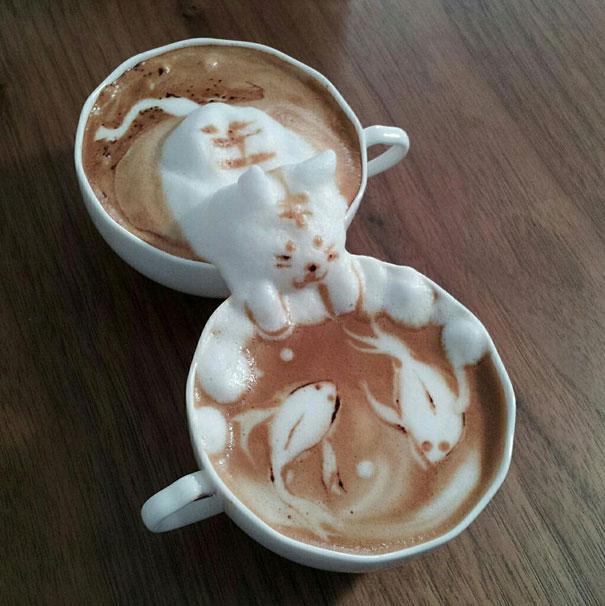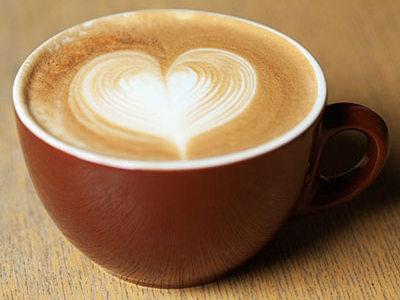The first image is the image on the left, the second image is the image on the right. Given the left and right images, does the statement "There is a milk design in a coffee." hold true? Answer yes or no. Yes. The first image is the image on the left, the second image is the image on the right. Assess this claim about the two images: "The left and right image contains a total of three full coffee cups.". Correct or not? Answer yes or no. Yes. 